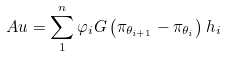Convert formula to latex. <formula><loc_0><loc_0><loc_500><loc_500>A u = \sum _ { 1 } ^ { n } \varphi _ { i } G \left ( \pi _ { \theta _ { i + 1 } } - \pi _ { \theta _ { i } } \right ) h _ { i }</formula> 